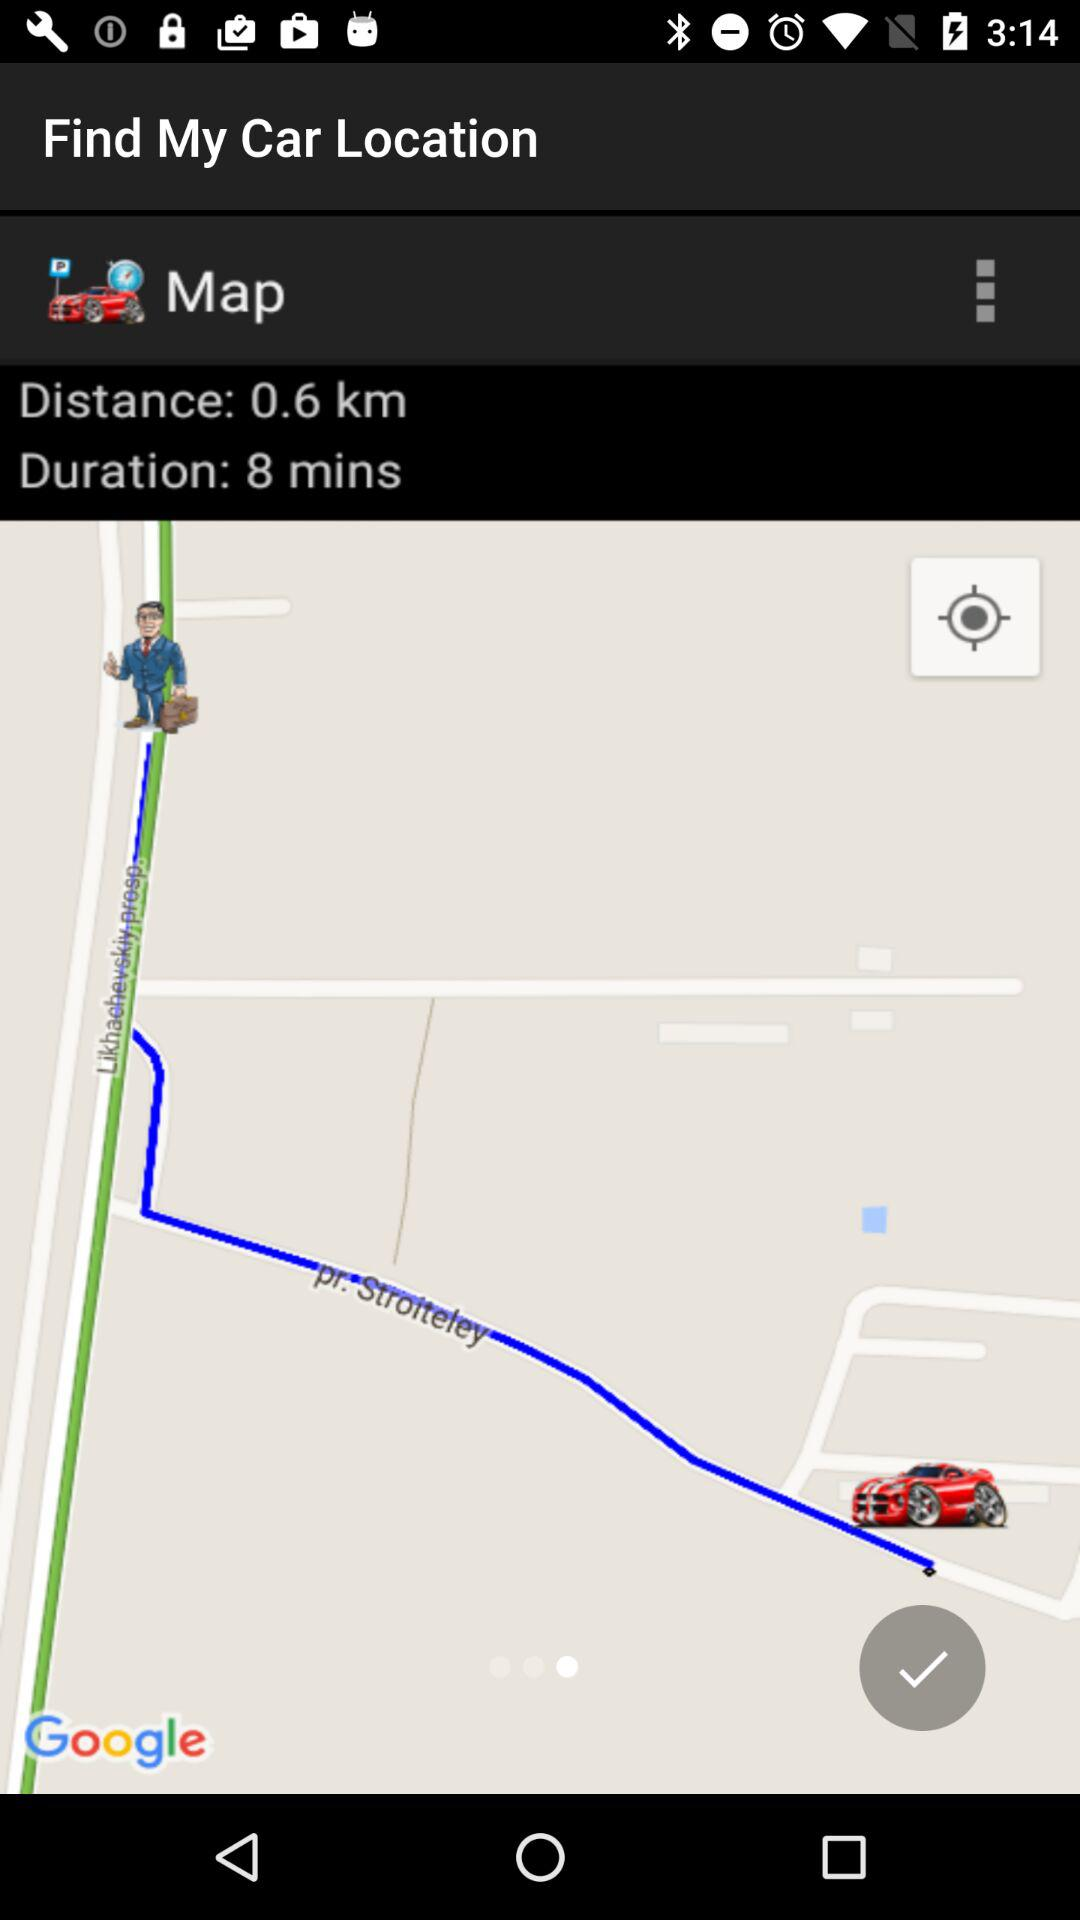What is the time duration to find my car? The time duration is 8 minutes. 